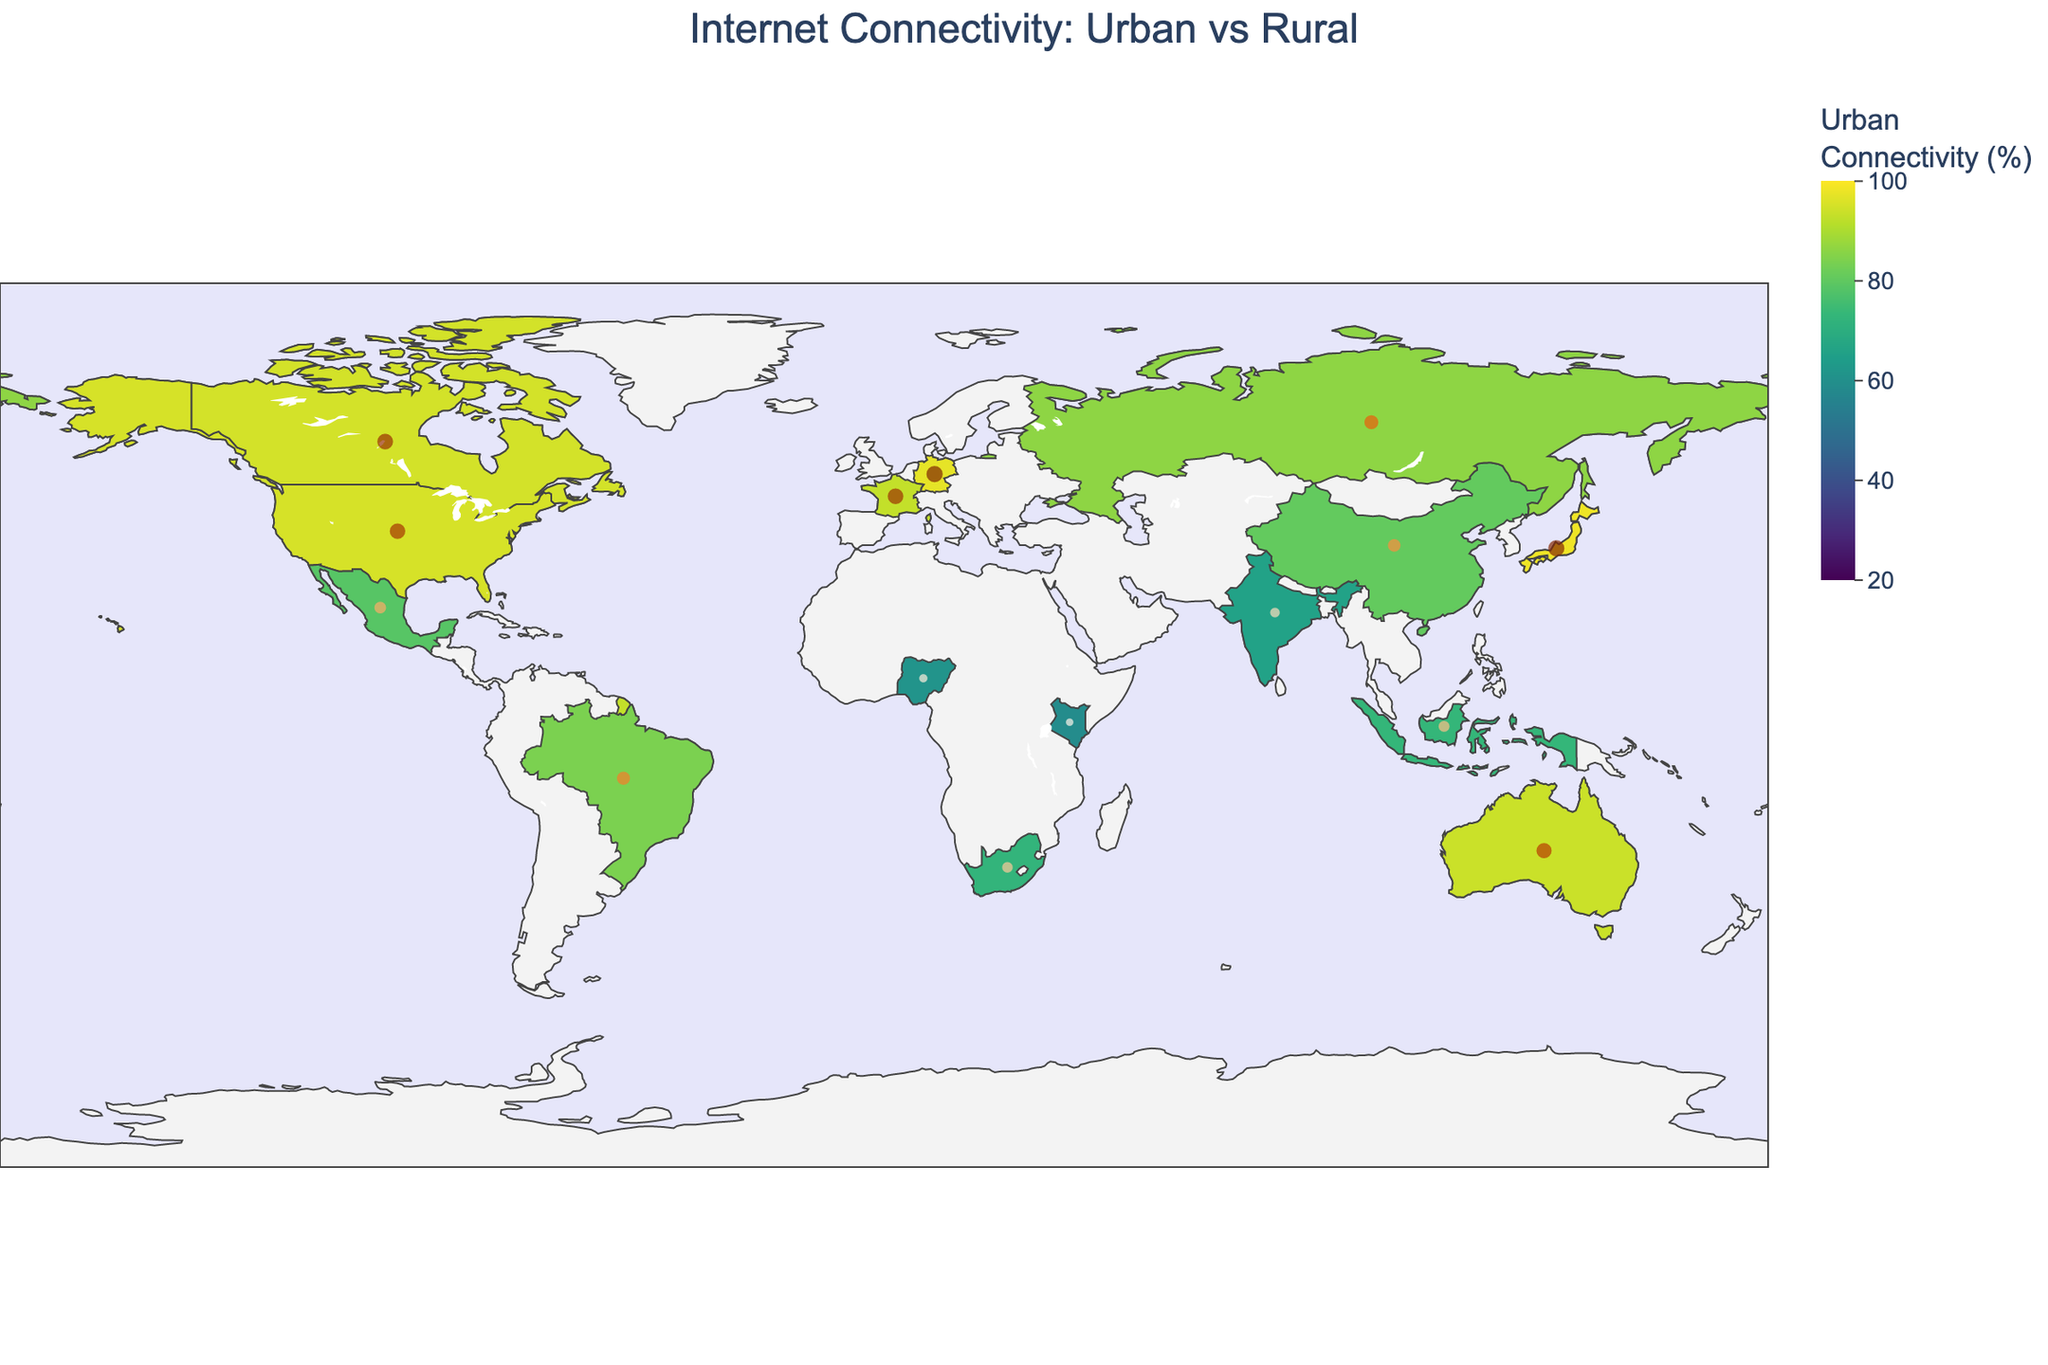Which country has the highest urban internet connectivity rate? Looking at the map or the color gradient for urban connectivity percentages, Japan shows the highest urban internet connectivity rate at 98.3%.
Answer: Japan Which country has the lowest rural internet connectivity rate? By examining the size and color of the markers for rural connectivity, Kenya has the lowest rural internet connectivity rate at 19.3%.
Answer: Kenya What is the difference between urban and rural connectivity rates in India? Urban connectivity in India is 65.8%, and rural connectivity is 32.1%. The difference is calculated as 65.8 - 32.1 = 33.7%.
Answer: 33.7% How does the rural connectivity rate in Canada compare to that in Germany? The connectivity rate for rural areas in Canada is 85.3%, while in Germany, it is 91.5%. Comparing these, Germany has a higher rural connectivity rate than Canada.
Answer: Germany Which countries have an urban internet connectivity rate higher than 90%? By checking the map, the countries with urban internet connectivity higher than 90% are the United States, Germany, Japan, Canada, and France.
Answer: United States, Germany, Japan, Canada, France Between urban and rural connectivity rates, which one shows greater variation across the countries? The map shows a greater color gradient variation and discrepancy in marker sizes for rural internet connectivity rates compared to urban connectivity rates, indicating higher variation.
Answer: Rural connectivity What is the average urban connectivity rate for the given countries? Summing the urban connectivity rates and dividing them by the number of countries: (95.2 + 80.5 + 65.8 + 83.9 + 97.1 + 61.2 + 93.7 + 98.3 + 78.6 + 72.4 + 86.2 + 73.1 + 94.8 + 92.9 + 58.7) / 15 = 82.8%
Answer: 82.8% If a country has 40% rural connectivity, is its urban connectivity likely to be above or below 75%? Observing the dataset, countries with lower rural connectivity generally have a lower urban connectivity as well. Therefore, if rural connectivity is 40%, urban connectivity is likely to be below 75%.
Answer: Below 75% What is the urban connectivity rate in South Africa and how much higher is it compared to its rural connectivity rate? The urban connectivity rate in South Africa is 72.4%. Its rural connectivity rate is 38.9%. The difference is calculated as 72.4 - 38.9 = 33.5%.
Answer: 72.4%, 33.5% Which country shows a significant improvement in rural connectivity compared to other developing countries? Among the developing countries listed, China shows a relatively higher rural connectivity rate at 55.3%, suggesting significant improvement compared to countries like India (32.1%) and Nigeria (23.8%).
Answer: China 